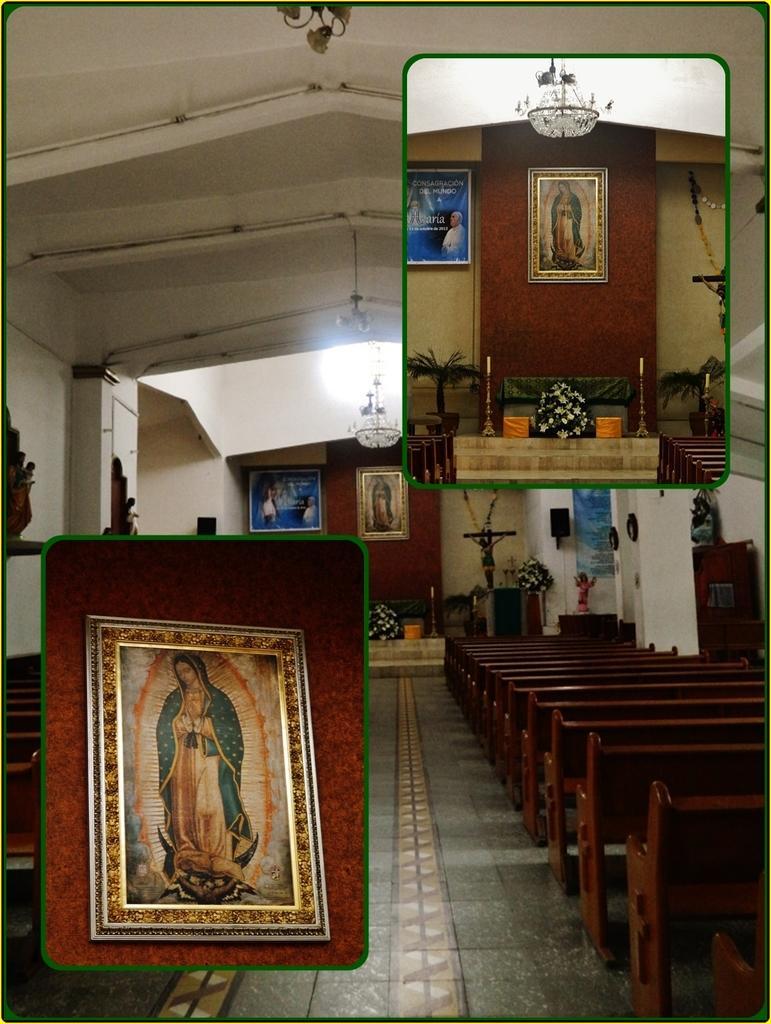Could you give a brief overview of what you see in this image? This is an edited image and this image is taken from inside the church. In the foreground of the image there are two photos and there are benches arranged to the left and right side of the image, there are a few frames hanging on the wall and there is a flower pot, there is a statue of Jesus Christ. At the top of the image there is a ceiling with lights and there is a chandelier. 